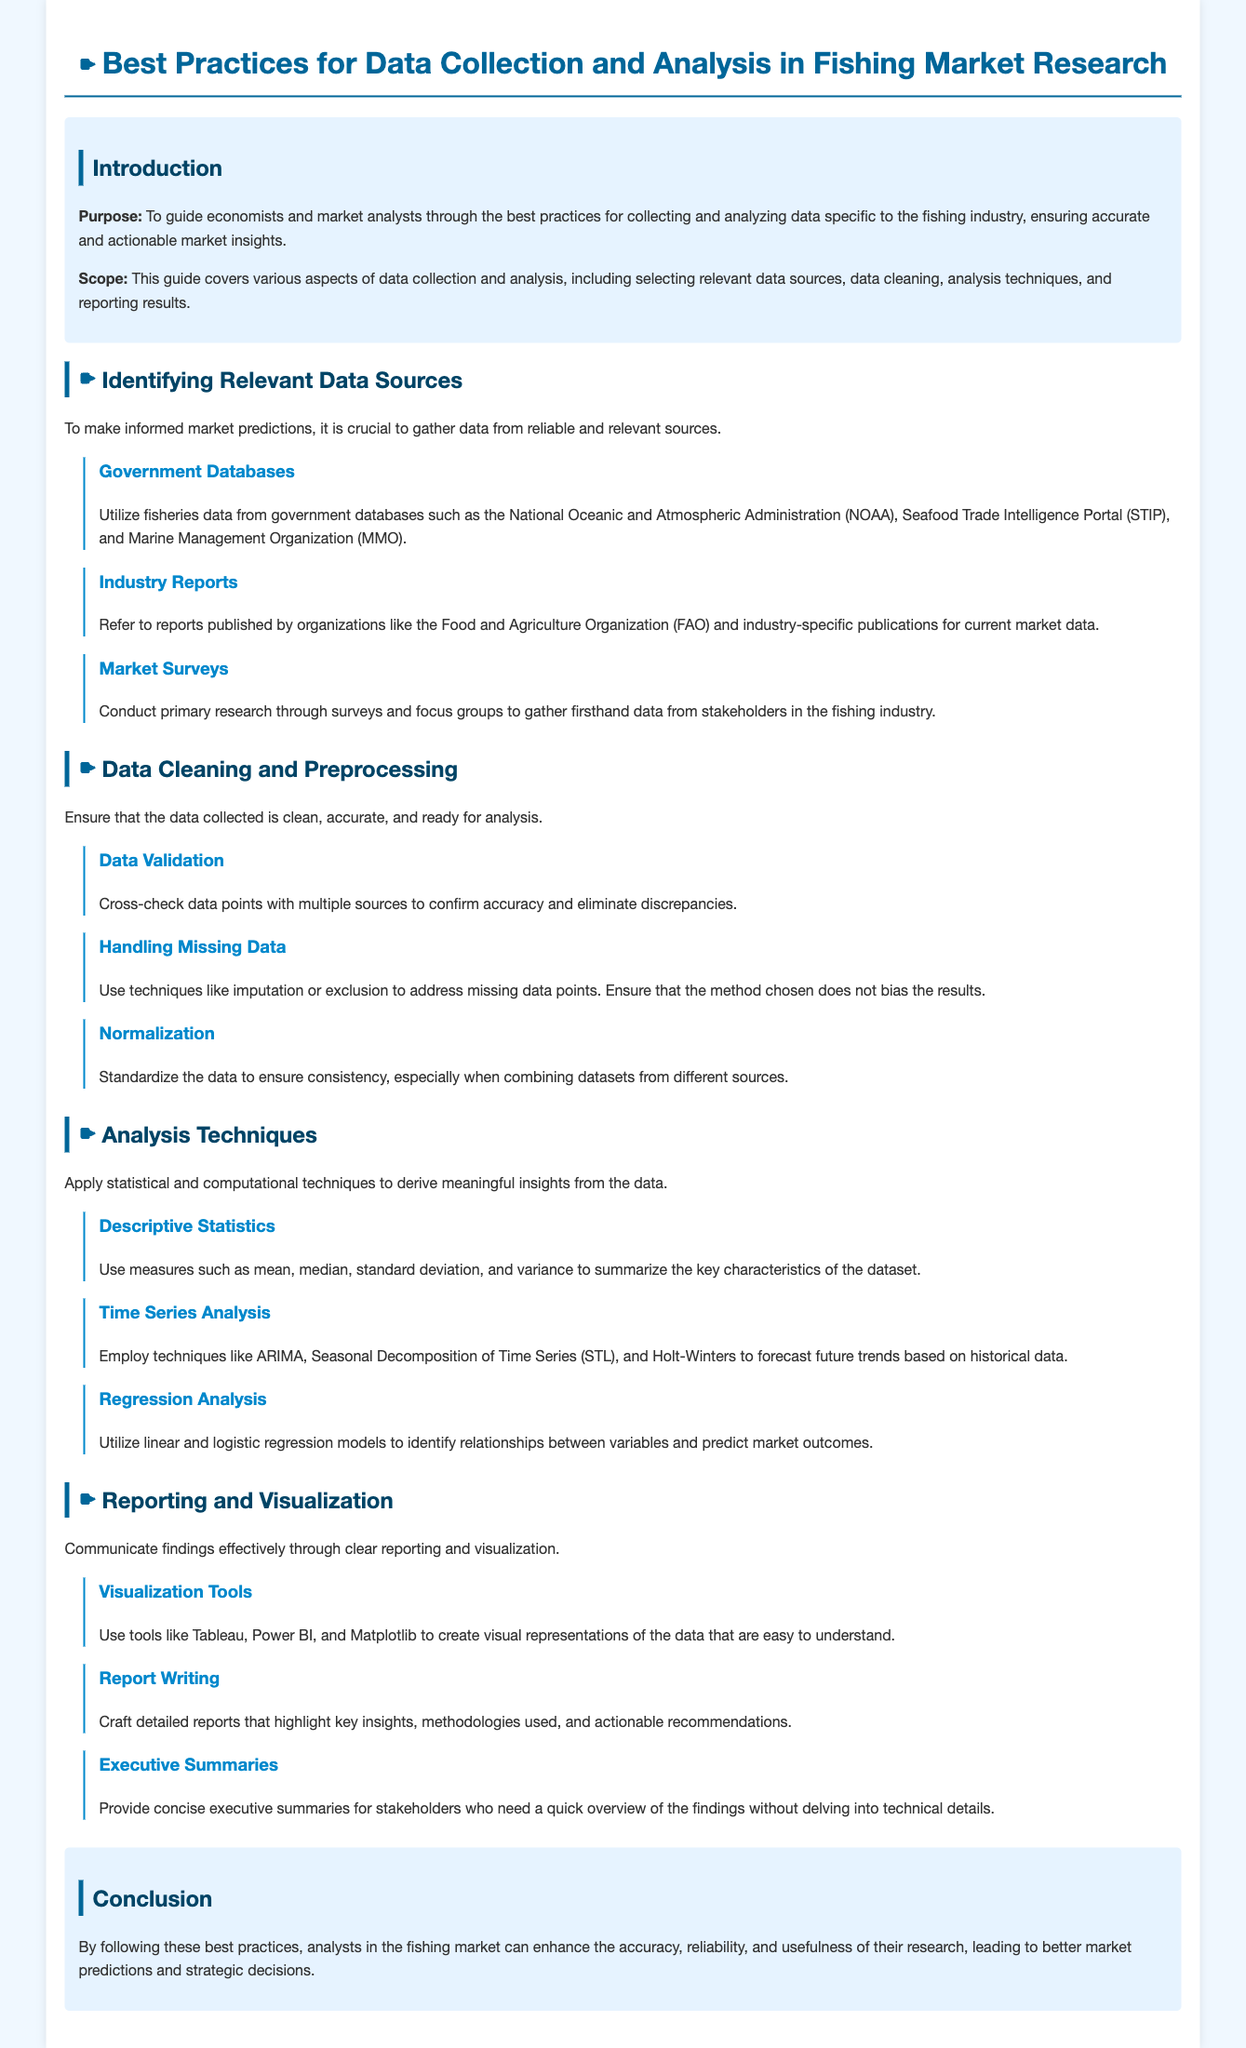What is the purpose of the guide? The purpose of the guide is to guide economists and market analysts through the best practices for collecting and analyzing data specific to the fishing industry, ensuring accurate and actionable market insights.
Answer: To guide economists and market analysts through the best practices for collecting and analyzing data specific to the fishing industry, ensuring accurate and actionable market insights Which organization provides fisheries data? The document mentions the National Oceanic and Atmospheric Administration (NOAA) as a reliable source for fisheries data.
Answer: National Oceanic and Atmospheric Administration What is one technique for handling missing data? The document suggests using techniques like imputation or exclusion to address missing data points.
Answer: Imputation What analysis technique is used to forecast future trends? Techniques like ARIMA, Seasonal Decomposition of Time Series, and Holt-Winters are mentioned for forecasting future trends based on historical data.
Answer: ARIMA What should visual representations of data be? The document states that visual representations of the data should be easy to understand.
Answer: Easy to understand What is emphasized in report writing? The document emphasizes crafting detailed reports that highlight key insights, methodologies used, and actionable recommendations in report writing.
Answer: Key insights, methodologies used, and actionable recommendations Which tool is recommended for data visualization? The document mentions Tableau, Power BI, and Matplotlib as tools for creating visual representations of data.
Answer: Tableau What is the conclusion of the guide? The conclusion highlights that following best practices enhances the accuracy, reliability, and usefulness of research in the fishing market, leading to better predictions.
Answer: Enhances the accuracy, reliability, and usefulness of research in the fishing market 